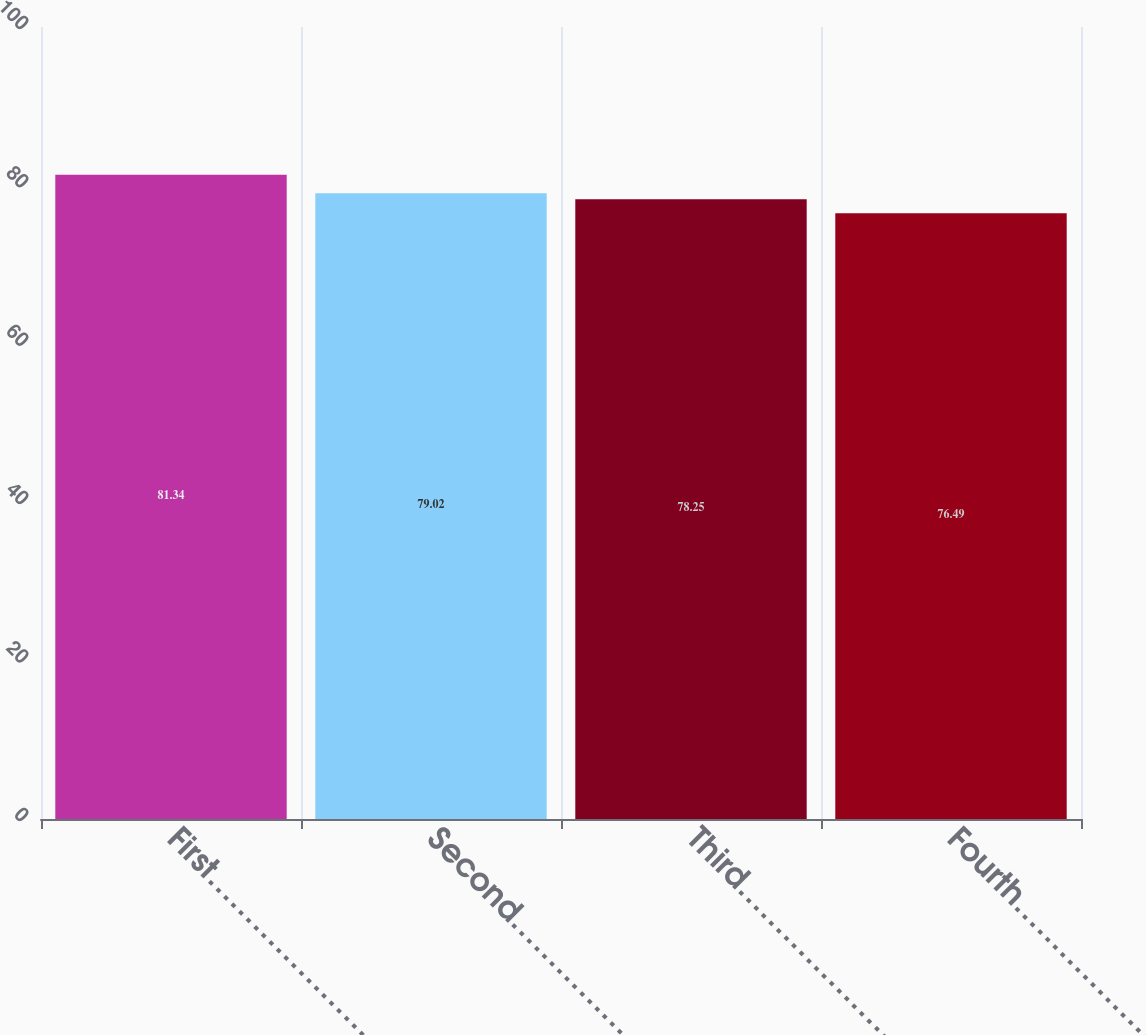Convert chart. <chart><loc_0><loc_0><loc_500><loc_500><bar_chart><fcel>First………………………………………<fcel>Second……………………………………<fcel>Third………………………………………<fcel>Fourth……………………………………<nl><fcel>81.34<fcel>79.02<fcel>78.25<fcel>76.49<nl></chart> 